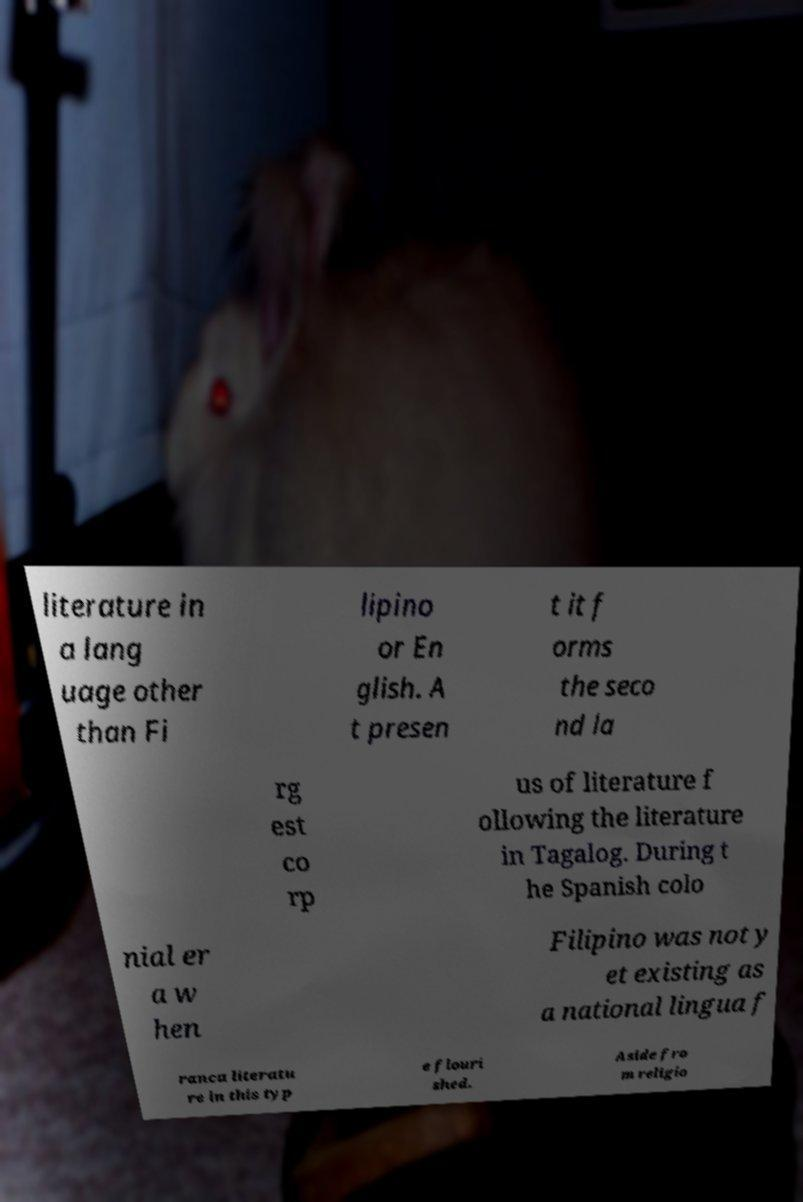For documentation purposes, I need the text within this image transcribed. Could you provide that? literature in a lang uage other than Fi lipino or En glish. A t presen t it f orms the seco nd la rg est co rp us of literature f ollowing the literature in Tagalog. During t he Spanish colo nial er a w hen Filipino was not y et existing as a national lingua f ranca literatu re in this typ e flouri shed. Aside fro m religio 